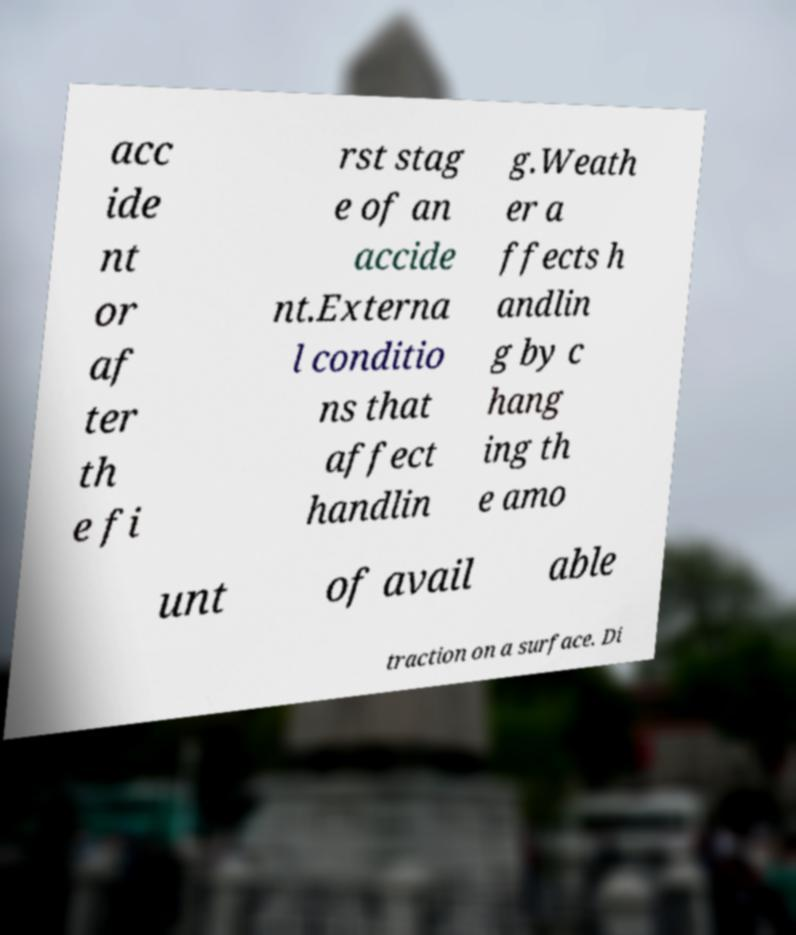There's text embedded in this image that I need extracted. Can you transcribe it verbatim? acc ide nt or af ter th e fi rst stag e of an accide nt.Externa l conditio ns that affect handlin g.Weath er a ffects h andlin g by c hang ing th e amo unt of avail able traction on a surface. Di 